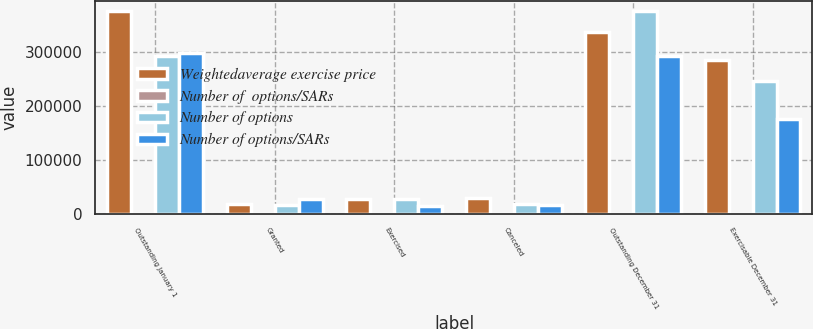Convert chart. <chart><loc_0><loc_0><loc_500><loc_500><stacked_bar_chart><ecel><fcel>Outstanding January 1<fcel>Granted<fcel>Exercised<fcel>Canceled<fcel>Outstanding December 31<fcel>Exercisable December 31<nl><fcel>Weightedaverage exercise price<fcel>376330<fcel>17248<fcel>26731<fcel>28272<fcel>338575<fcel>286017<nl><fcel>Number of  options/SARs<fcel>37.59<fcel>35.55<fcel>24.28<fcel>44.77<fcel>37.93<fcel>38.89<nl><fcel>Number of options<fcel>294026<fcel>16667<fcel>27763<fcel>17887<fcel>376330<fcel>246945<nl><fcel>Number of options/SARs<fcel>298731<fcel>26751<fcel>14574<fcel>16882<fcel>294026<fcel>176163<nl></chart> 